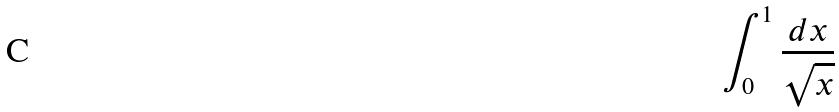<formula> <loc_0><loc_0><loc_500><loc_500>\int _ { 0 } ^ { 1 } \frac { d x } { \sqrt { x } }</formula> 